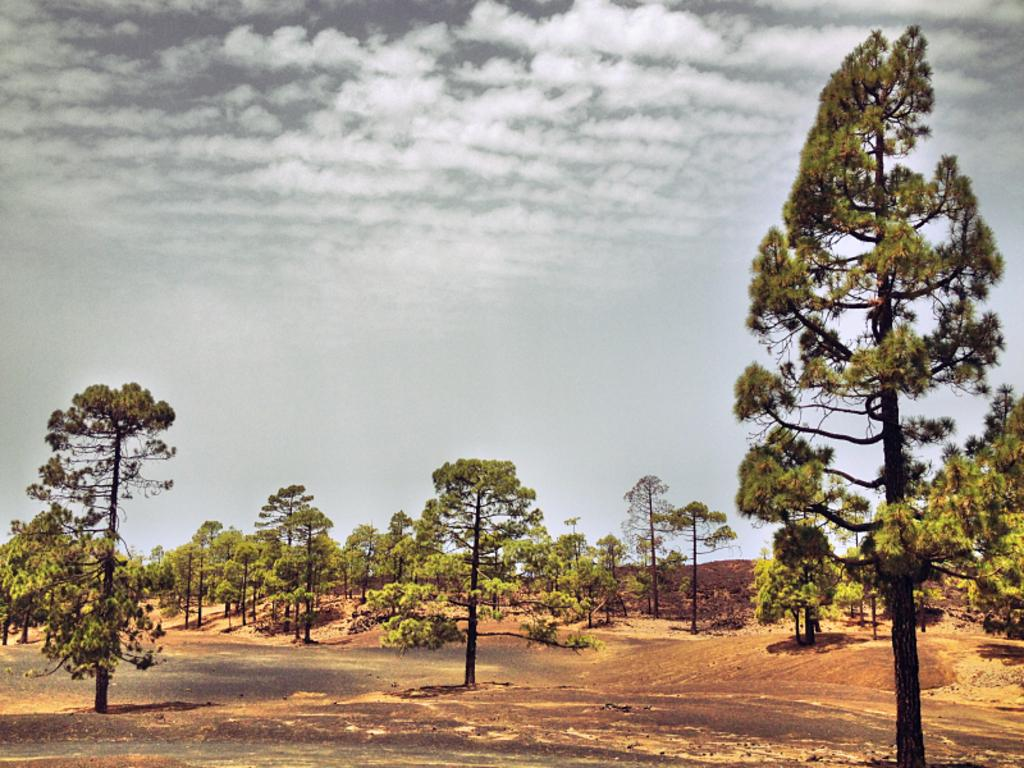What type of vegetation can be seen in the image? There are trees in the image. What is visible in the background of the image? The sky is visible in the image. What can be seen in the sky in the image? Clouds are present in the image. What type of card is being used to design the sun in the image? There is no card or sun present in the image; it features trees and clouds in the sky. 